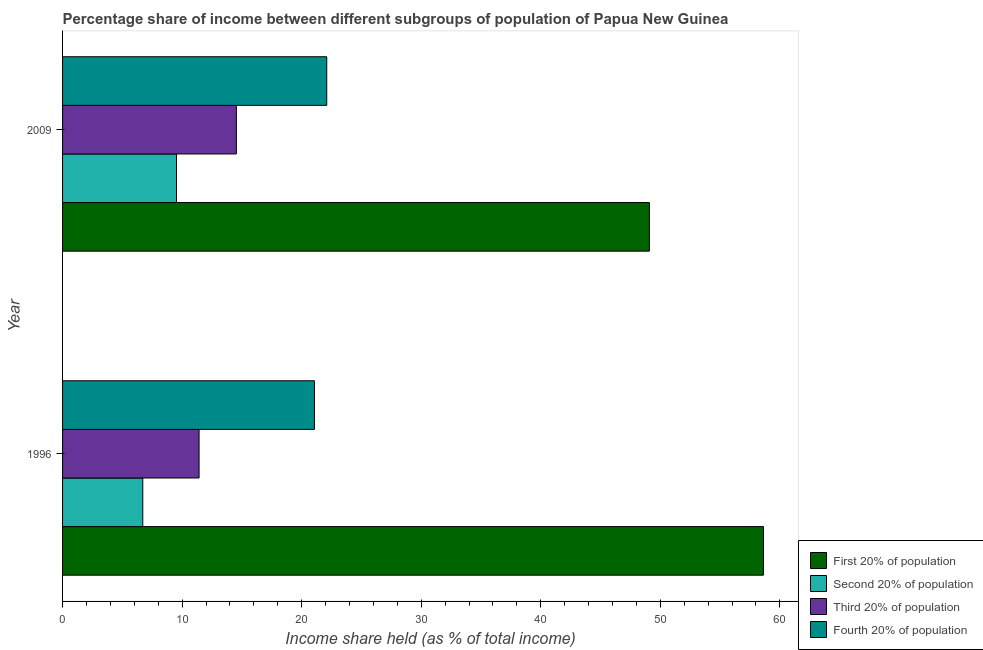How many different coloured bars are there?
Offer a very short reply. 4. Are the number of bars on each tick of the Y-axis equal?
Ensure brevity in your answer.  Yes. How many bars are there on the 2nd tick from the top?
Provide a succinct answer. 4. What is the label of the 1st group of bars from the top?
Your answer should be compact. 2009. What is the share of the income held by second 20% of the population in 2009?
Provide a short and direct response. 9.53. Across all years, what is the maximum share of the income held by third 20% of the population?
Your answer should be compact. 14.54. Across all years, what is the minimum share of the income held by third 20% of the population?
Your answer should be very brief. 11.42. What is the total share of the income held by fourth 20% of the population in the graph?
Your answer should be very brief. 43.17. What is the difference between the share of the income held by third 20% of the population in 1996 and that in 2009?
Your response must be concise. -3.12. What is the difference between the share of the income held by second 20% of the population in 1996 and the share of the income held by first 20% of the population in 2009?
Your answer should be very brief. -42.38. What is the average share of the income held by second 20% of the population per year?
Offer a very short reply. 8.12. In the year 1996, what is the difference between the share of the income held by fourth 20% of the population and share of the income held by second 20% of the population?
Give a very brief answer. 14.36. What is the ratio of the share of the income held by second 20% of the population in 1996 to that in 2009?
Ensure brevity in your answer.  0.7. Is the difference between the share of the income held by fourth 20% of the population in 1996 and 2009 greater than the difference between the share of the income held by second 20% of the population in 1996 and 2009?
Ensure brevity in your answer.  Yes. Is it the case that in every year, the sum of the share of the income held by first 20% of the population and share of the income held by third 20% of the population is greater than the sum of share of the income held by fourth 20% of the population and share of the income held by second 20% of the population?
Offer a terse response. Yes. What does the 3rd bar from the top in 1996 represents?
Offer a terse response. Second 20% of population. What does the 4th bar from the bottom in 1996 represents?
Provide a short and direct response. Fourth 20% of population. Is it the case that in every year, the sum of the share of the income held by first 20% of the population and share of the income held by second 20% of the population is greater than the share of the income held by third 20% of the population?
Provide a short and direct response. Yes. Are the values on the major ticks of X-axis written in scientific E-notation?
Offer a terse response. No. Does the graph contain grids?
Your answer should be compact. No. How many legend labels are there?
Make the answer very short. 4. How are the legend labels stacked?
Your answer should be compact. Vertical. What is the title of the graph?
Keep it short and to the point. Percentage share of income between different subgroups of population of Papua New Guinea. Does "HFC gas" appear as one of the legend labels in the graph?
Provide a short and direct response. No. What is the label or title of the X-axis?
Keep it short and to the point. Income share held (as % of total income). What is the label or title of the Y-axis?
Make the answer very short. Year. What is the Income share held (as % of total income) in First 20% of population in 1996?
Your answer should be very brief. 58.63. What is the Income share held (as % of total income) of Second 20% of population in 1996?
Offer a very short reply. 6.71. What is the Income share held (as % of total income) in Third 20% of population in 1996?
Provide a succinct answer. 11.42. What is the Income share held (as % of total income) in Fourth 20% of population in 1996?
Your answer should be very brief. 21.07. What is the Income share held (as % of total income) in First 20% of population in 2009?
Give a very brief answer. 49.09. What is the Income share held (as % of total income) of Second 20% of population in 2009?
Make the answer very short. 9.53. What is the Income share held (as % of total income) of Third 20% of population in 2009?
Provide a short and direct response. 14.54. What is the Income share held (as % of total income) in Fourth 20% of population in 2009?
Ensure brevity in your answer.  22.1. Across all years, what is the maximum Income share held (as % of total income) of First 20% of population?
Ensure brevity in your answer.  58.63. Across all years, what is the maximum Income share held (as % of total income) in Second 20% of population?
Your response must be concise. 9.53. Across all years, what is the maximum Income share held (as % of total income) in Third 20% of population?
Give a very brief answer. 14.54. Across all years, what is the maximum Income share held (as % of total income) in Fourth 20% of population?
Provide a succinct answer. 22.1. Across all years, what is the minimum Income share held (as % of total income) of First 20% of population?
Provide a short and direct response. 49.09. Across all years, what is the minimum Income share held (as % of total income) in Second 20% of population?
Offer a very short reply. 6.71. Across all years, what is the minimum Income share held (as % of total income) of Third 20% of population?
Keep it short and to the point. 11.42. Across all years, what is the minimum Income share held (as % of total income) in Fourth 20% of population?
Make the answer very short. 21.07. What is the total Income share held (as % of total income) in First 20% of population in the graph?
Your answer should be compact. 107.72. What is the total Income share held (as % of total income) in Second 20% of population in the graph?
Offer a terse response. 16.24. What is the total Income share held (as % of total income) of Third 20% of population in the graph?
Keep it short and to the point. 25.96. What is the total Income share held (as % of total income) in Fourth 20% of population in the graph?
Make the answer very short. 43.17. What is the difference between the Income share held (as % of total income) of First 20% of population in 1996 and that in 2009?
Offer a terse response. 9.54. What is the difference between the Income share held (as % of total income) of Second 20% of population in 1996 and that in 2009?
Your answer should be very brief. -2.82. What is the difference between the Income share held (as % of total income) in Third 20% of population in 1996 and that in 2009?
Make the answer very short. -3.12. What is the difference between the Income share held (as % of total income) of Fourth 20% of population in 1996 and that in 2009?
Give a very brief answer. -1.03. What is the difference between the Income share held (as % of total income) of First 20% of population in 1996 and the Income share held (as % of total income) of Second 20% of population in 2009?
Provide a short and direct response. 49.1. What is the difference between the Income share held (as % of total income) of First 20% of population in 1996 and the Income share held (as % of total income) of Third 20% of population in 2009?
Your answer should be compact. 44.09. What is the difference between the Income share held (as % of total income) in First 20% of population in 1996 and the Income share held (as % of total income) in Fourth 20% of population in 2009?
Keep it short and to the point. 36.53. What is the difference between the Income share held (as % of total income) in Second 20% of population in 1996 and the Income share held (as % of total income) in Third 20% of population in 2009?
Your answer should be very brief. -7.83. What is the difference between the Income share held (as % of total income) in Second 20% of population in 1996 and the Income share held (as % of total income) in Fourth 20% of population in 2009?
Provide a succinct answer. -15.39. What is the difference between the Income share held (as % of total income) of Third 20% of population in 1996 and the Income share held (as % of total income) of Fourth 20% of population in 2009?
Your answer should be compact. -10.68. What is the average Income share held (as % of total income) in First 20% of population per year?
Offer a terse response. 53.86. What is the average Income share held (as % of total income) of Second 20% of population per year?
Ensure brevity in your answer.  8.12. What is the average Income share held (as % of total income) in Third 20% of population per year?
Your answer should be compact. 12.98. What is the average Income share held (as % of total income) in Fourth 20% of population per year?
Provide a short and direct response. 21.59. In the year 1996, what is the difference between the Income share held (as % of total income) in First 20% of population and Income share held (as % of total income) in Second 20% of population?
Ensure brevity in your answer.  51.92. In the year 1996, what is the difference between the Income share held (as % of total income) in First 20% of population and Income share held (as % of total income) in Third 20% of population?
Give a very brief answer. 47.21. In the year 1996, what is the difference between the Income share held (as % of total income) in First 20% of population and Income share held (as % of total income) in Fourth 20% of population?
Keep it short and to the point. 37.56. In the year 1996, what is the difference between the Income share held (as % of total income) of Second 20% of population and Income share held (as % of total income) of Third 20% of population?
Offer a terse response. -4.71. In the year 1996, what is the difference between the Income share held (as % of total income) in Second 20% of population and Income share held (as % of total income) in Fourth 20% of population?
Your answer should be compact. -14.36. In the year 1996, what is the difference between the Income share held (as % of total income) in Third 20% of population and Income share held (as % of total income) in Fourth 20% of population?
Provide a succinct answer. -9.65. In the year 2009, what is the difference between the Income share held (as % of total income) in First 20% of population and Income share held (as % of total income) in Second 20% of population?
Make the answer very short. 39.56. In the year 2009, what is the difference between the Income share held (as % of total income) of First 20% of population and Income share held (as % of total income) of Third 20% of population?
Keep it short and to the point. 34.55. In the year 2009, what is the difference between the Income share held (as % of total income) of First 20% of population and Income share held (as % of total income) of Fourth 20% of population?
Offer a terse response. 26.99. In the year 2009, what is the difference between the Income share held (as % of total income) of Second 20% of population and Income share held (as % of total income) of Third 20% of population?
Your response must be concise. -5.01. In the year 2009, what is the difference between the Income share held (as % of total income) in Second 20% of population and Income share held (as % of total income) in Fourth 20% of population?
Your answer should be compact. -12.57. In the year 2009, what is the difference between the Income share held (as % of total income) of Third 20% of population and Income share held (as % of total income) of Fourth 20% of population?
Ensure brevity in your answer.  -7.56. What is the ratio of the Income share held (as % of total income) in First 20% of population in 1996 to that in 2009?
Ensure brevity in your answer.  1.19. What is the ratio of the Income share held (as % of total income) in Second 20% of population in 1996 to that in 2009?
Make the answer very short. 0.7. What is the ratio of the Income share held (as % of total income) of Third 20% of population in 1996 to that in 2009?
Keep it short and to the point. 0.79. What is the ratio of the Income share held (as % of total income) of Fourth 20% of population in 1996 to that in 2009?
Offer a very short reply. 0.95. What is the difference between the highest and the second highest Income share held (as % of total income) of First 20% of population?
Offer a terse response. 9.54. What is the difference between the highest and the second highest Income share held (as % of total income) of Second 20% of population?
Provide a short and direct response. 2.82. What is the difference between the highest and the second highest Income share held (as % of total income) in Third 20% of population?
Keep it short and to the point. 3.12. What is the difference between the highest and the lowest Income share held (as % of total income) of First 20% of population?
Keep it short and to the point. 9.54. What is the difference between the highest and the lowest Income share held (as % of total income) in Second 20% of population?
Make the answer very short. 2.82. What is the difference between the highest and the lowest Income share held (as % of total income) of Third 20% of population?
Provide a succinct answer. 3.12. What is the difference between the highest and the lowest Income share held (as % of total income) of Fourth 20% of population?
Give a very brief answer. 1.03. 